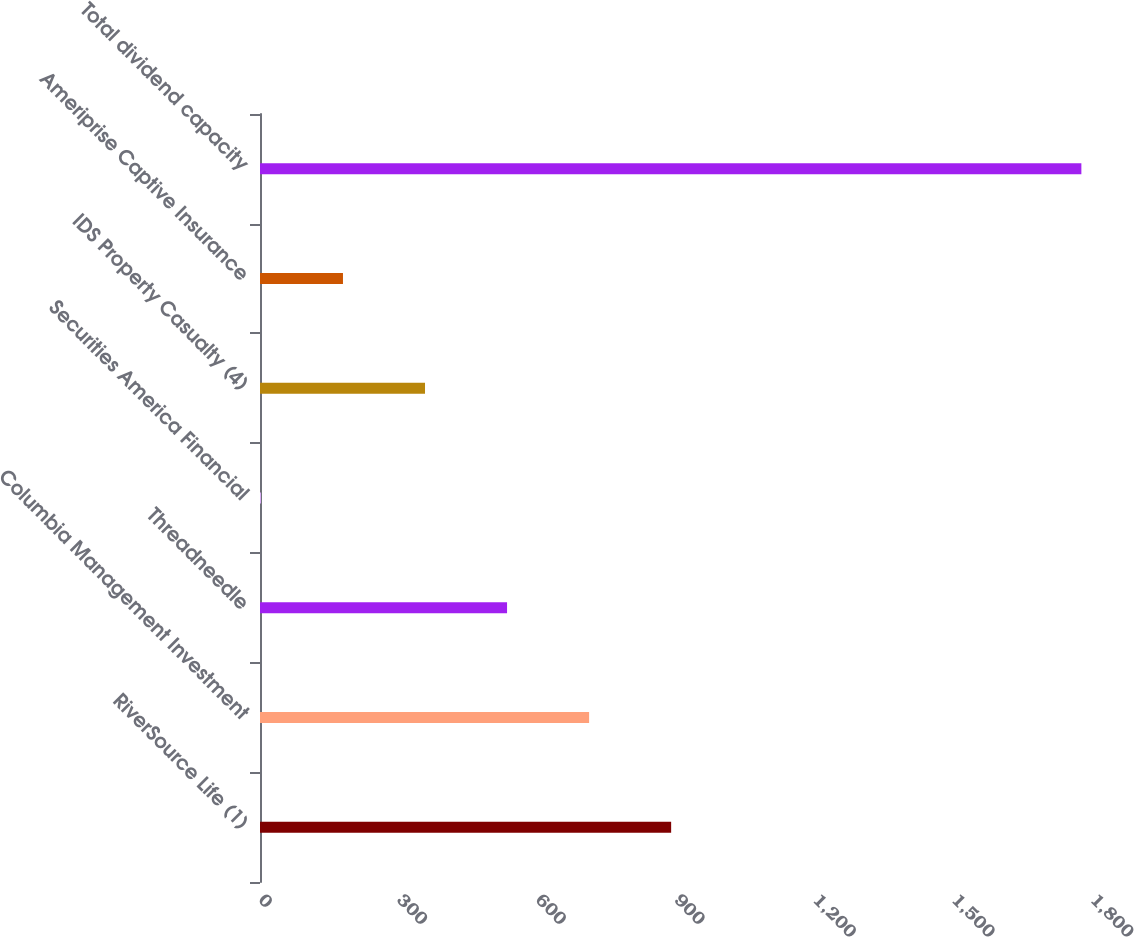<chart> <loc_0><loc_0><loc_500><loc_500><bar_chart><fcel>RiverSource Life (1)<fcel>Columbia Management Investment<fcel>Threadneedle<fcel>Securities America Financial<fcel>IDS Property Casualty (4)<fcel>Ameriprise Captive Insurance<fcel>Total dividend capacity<nl><fcel>889.5<fcel>712<fcel>534.5<fcel>2<fcel>357<fcel>179.5<fcel>1777<nl></chart> 